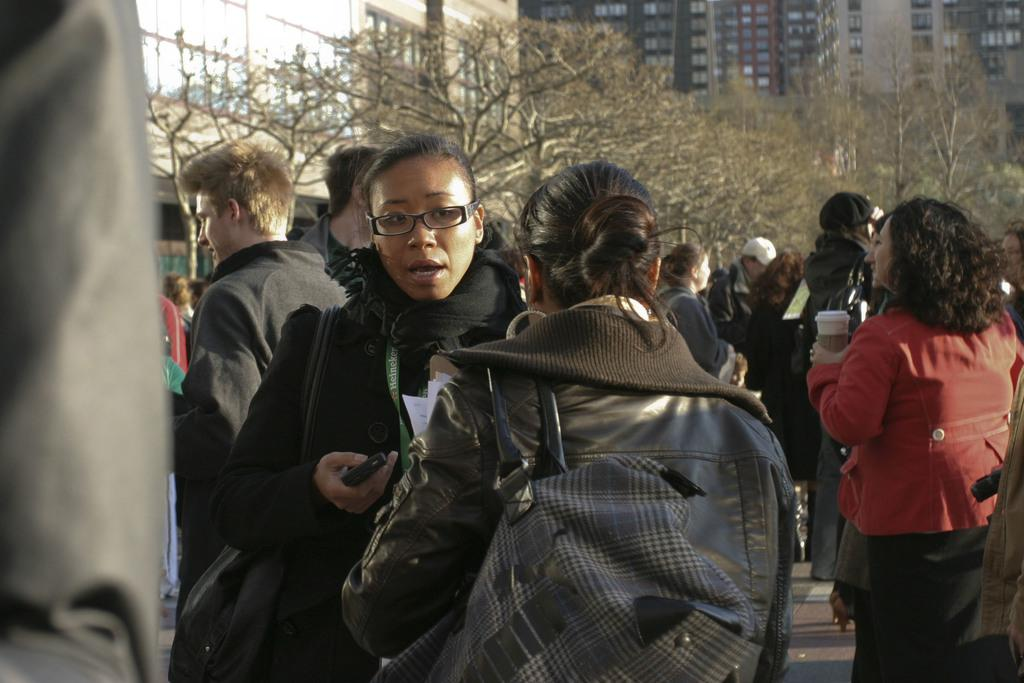What can be seen on the surface in the image? There are people standing on the surface in the image. What type of vegetation is visible in the image? There are trees visible in the image. What structures can be seen in the background of the image? There are buildings in the background of some kind in the background of the image. What type of skin condition can be seen on the people in the image? There is no indication of any skin condition on the people in the image. What type of soda is being served at the event in the image? There is: There is no event or soda present in the image. How many crows are visible in the image? There are no crows present in the image. 